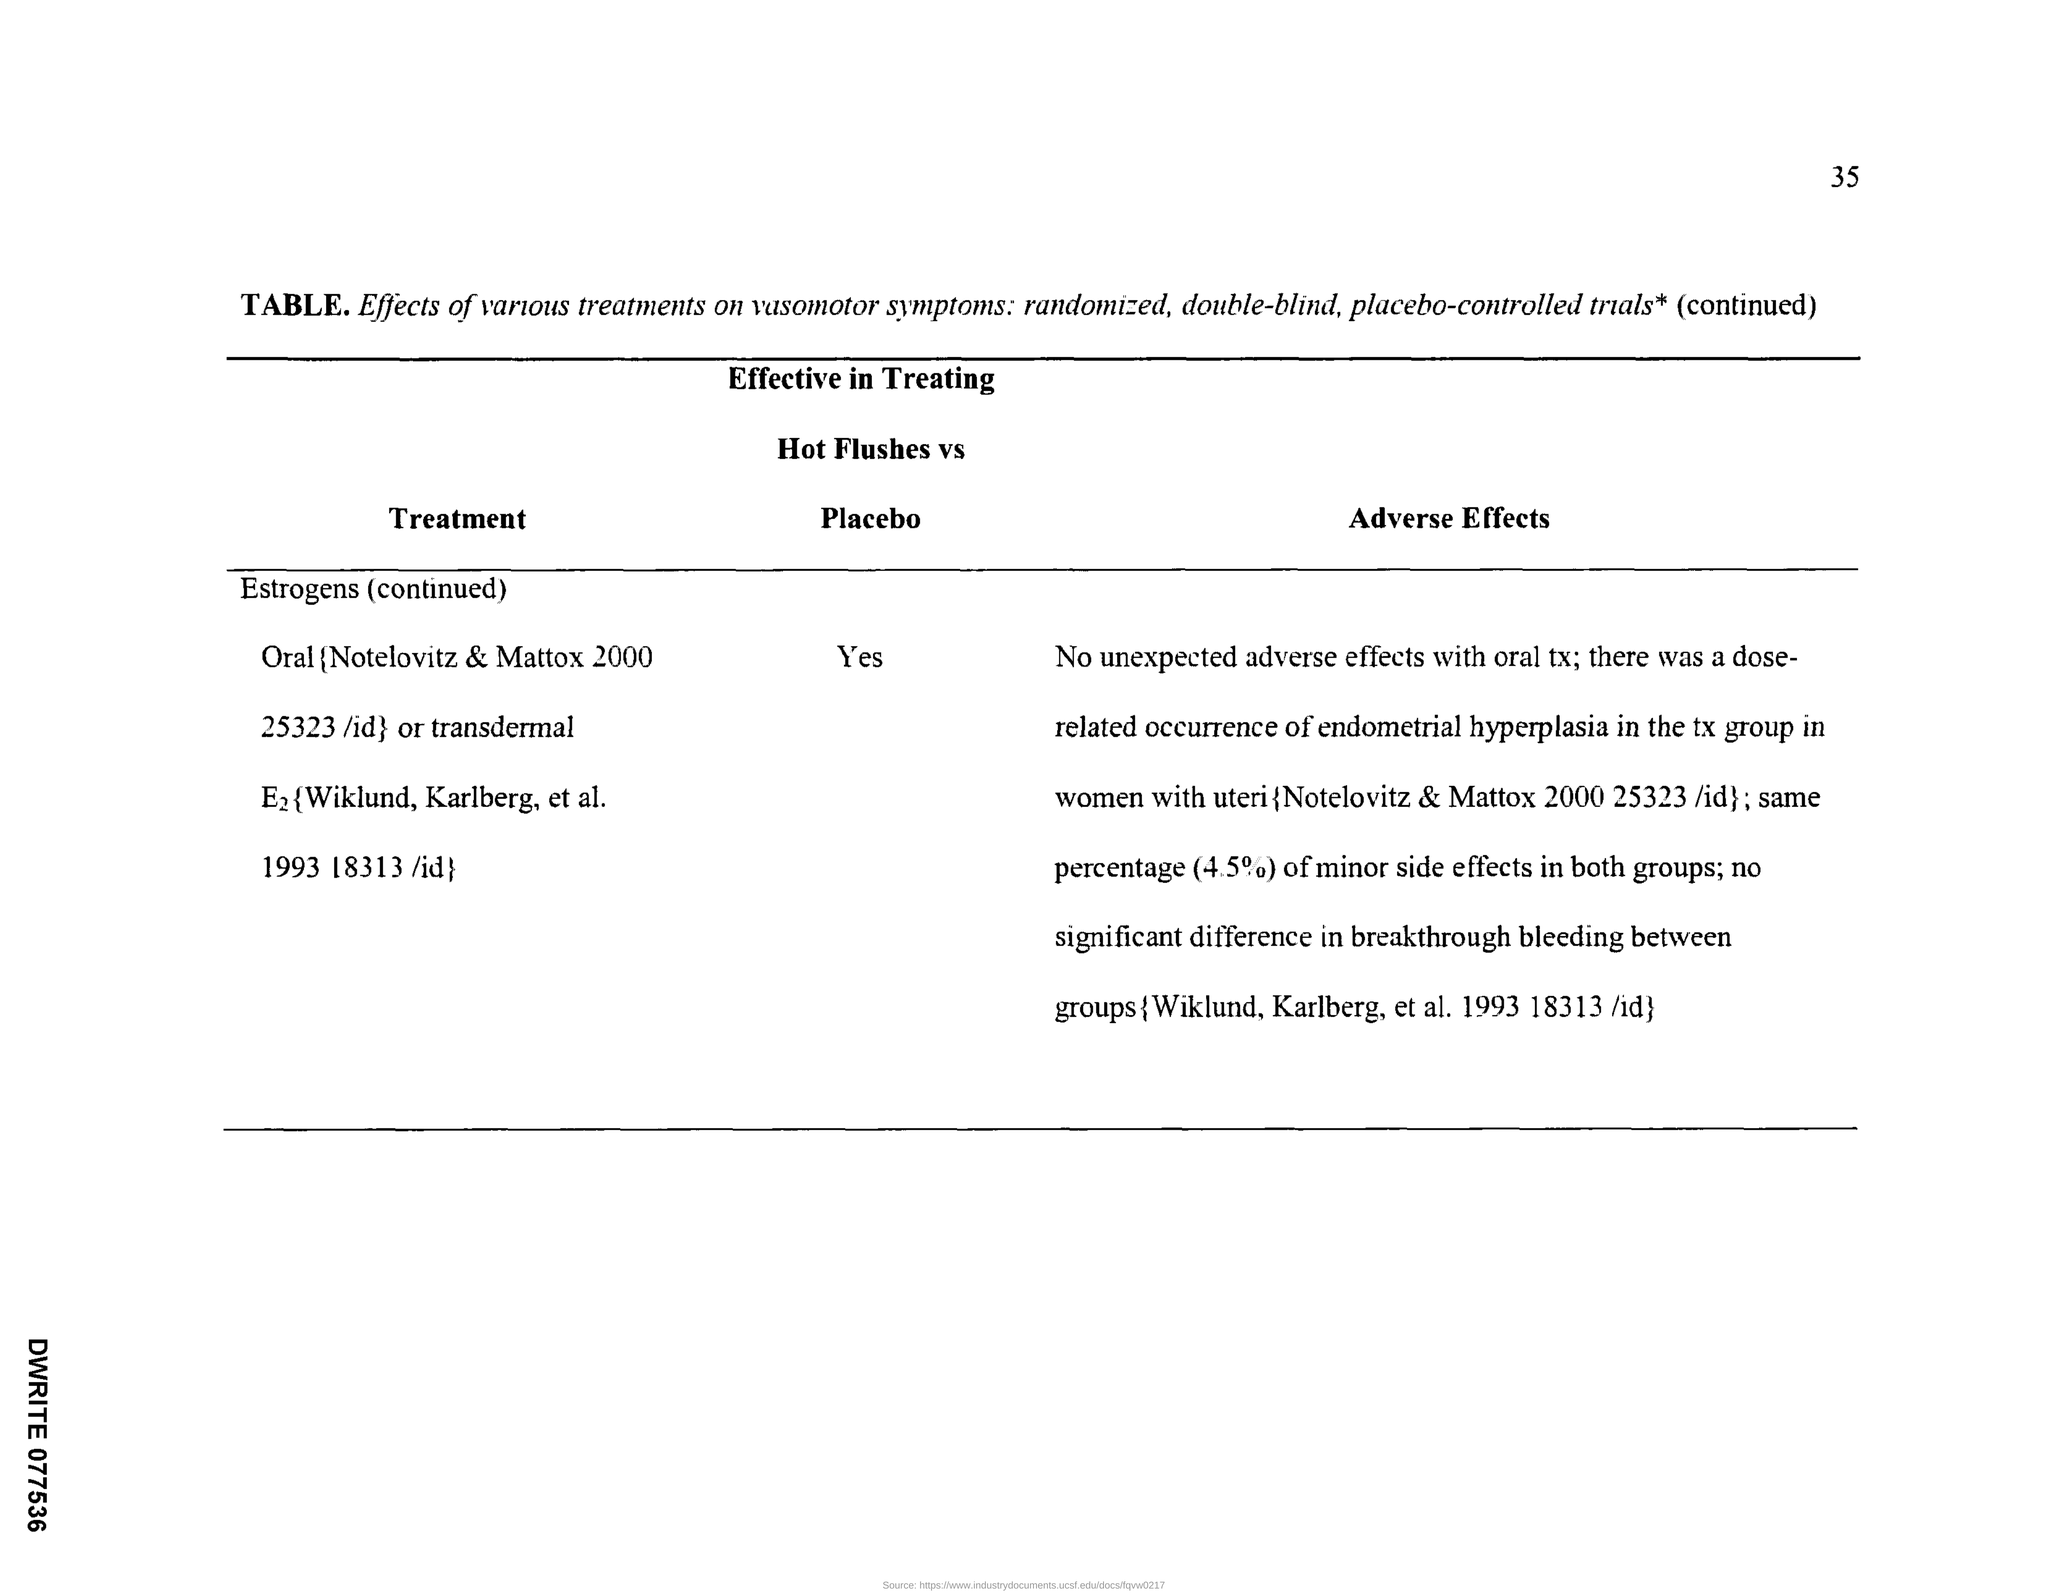Give some essential details in this illustration. Estrogen is an effective treatment for hot flushes when compared to a placebo. The page number is 35 